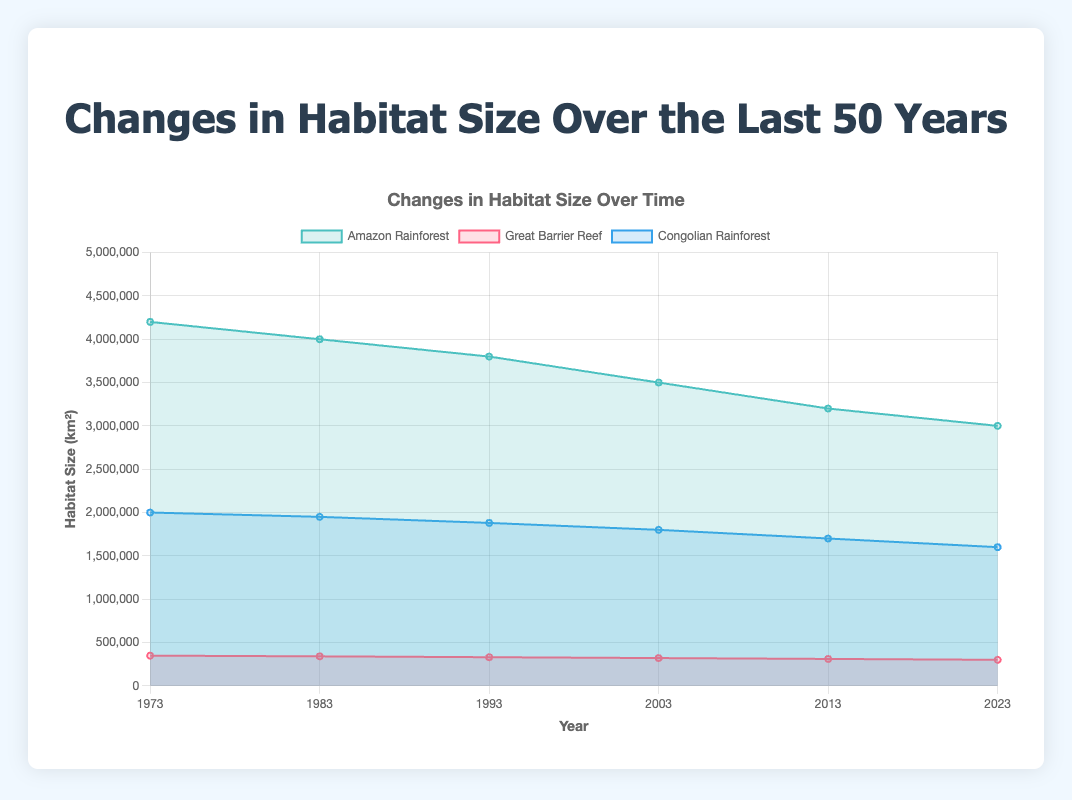What is the title of the chart? The title of the chart can be found at the top, usually indicating the subject being visualized.
Answer: Changes in Habitat Size Over the Last 50 Years Which habitat has the largest size in 1973? In the figure, the dataset for 1973 shows three habitats with their respective sizes. By comparing their values, you can identify the largest habitat.
Answer: Amazon Rainforest How has the size of the Great Barrier Reef changed from 1973 to 2023? By looking at the values on the y-axis corresponding to the Great Barrier Reef's data points for the years 1973 and 2023, you can see the difference in size.
Answer: Decreased What is the overall trend in the habitat size of the Amazon Rainforest from 1973 to 2023? Observing the Amazon Rainforest's data across the x-axis from 1973 to 2023 allows you to see the direction of data points, indicating the trend.
Answer: Decreasing Compare the habitat size of the Congolian Rainforest and the Amazon Rainforest in 2003. Which one is larger? By comparing the data points for both habitats in the year 2003, you can determine which one has a higher value on the y-axis.
Answer: Amazon Rainforest In what year did the Amazon Rainforest see the largest decline in size from the previous decade? Review the changes in size for each subsequent decade and identify the period with the greatest drop in the Amazon Rainforest's size.
Answer: 1993 On average, how much did the size of the Great Barrier Reef decrease per decade? Determine the difference in size from the first to the last data points, then divide by the number of decades (5 intervals from 1973 to 2023).
Answer: 9,600 km² per decade Which habitat experienced the smallest decline in quality index over the 50 years? By comparing the differences in the quality index values from 1973 to 2023 for each habitat, identify the one with the smallest decline.
Answer: Amazon Rainforest What is the approximate total habitat size for all three regions in 2023? Sum the habitat size of the Amazon Rainforest, Great Barrier Reef, and Congolian Rainforest for the year 2023.
Answer: 4,900,000 km² Between which two successive decades did the Congolian Rainforest experience the most significant quality index drop? Compare the quality index values for each successive decade and find the greatest decrease.
Answer: 1993 to 2003 